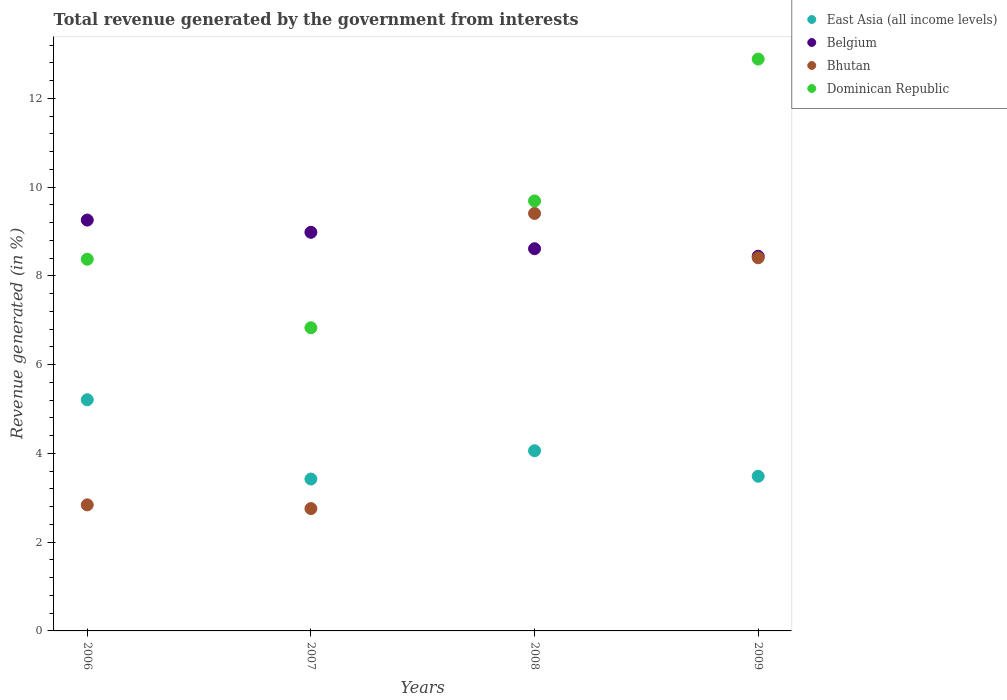How many different coloured dotlines are there?
Your response must be concise. 4. Is the number of dotlines equal to the number of legend labels?
Keep it short and to the point. Yes. What is the total revenue generated in Bhutan in 2006?
Provide a short and direct response. 2.84. Across all years, what is the maximum total revenue generated in Dominican Republic?
Ensure brevity in your answer.  12.88. Across all years, what is the minimum total revenue generated in Belgium?
Ensure brevity in your answer.  8.44. What is the total total revenue generated in Bhutan in the graph?
Provide a short and direct response. 23.41. What is the difference between the total revenue generated in Belgium in 2008 and that in 2009?
Keep it short and to the point. 0.17. What is the difference between the total revenue generated in Bhutan in 2006 and the total revenue generated in Dominican Republic in 2007?
Provide a succinct answer. -3.99. What is the average total revenue generated in Bhutan per year?
Ensure brevity in your answer.  5.85. In the year 2008, what is the difference between the total revenue generated in East Asia (all income levels) and total revenue generated in Belgium?
Your answer should be compact. -4.55. In how many years, is the total revenue generated in Bhutan greater than 4 %?
Your response must be concise. 2. What is the ratio of the total revenue generated in Belgium in 2006 to that in 2008?
Your response must be concise. 1.07. Is the difference between the total revenue generated in East Asia (all income levels) in 2006 and 2009 greater than the difference between the total revenue generated in Belgium in 2006 and 2009?
Your response must be concise. Yes. What is the difference between the highest and the second highest total revenue generated in Belgium?
Your response must be concise. 0.28. What is the difference between the highest and the lowest total revenue generated in Dominican Republic?
Give a very brief answer. 6.05. Is the sum of the total revenue generated in Bhutan in 2007 and 2009 greater than the maximum total revenue generated in Belgium across all years?
Make the answer very short. Yes. Is it the case that in every year, the sum of the total revenue generated in Bhutan and total revenue generated in Dominican Republic  is greater than the sum of total revenue generated in Belgium and total revenue generated in East Asia (all income levels)?
Your answer should be very brief. No. Is it the case that in every year, the sum of the total revenue generated in Belgium and total revenue generated in East Asia (all income levels)  is greater than the total revenue generated in Bhutan?
Give a very brief answer. Yes. Does the total revenue generated in Bhutan monotonically increase over the years?
Your answer should be compact. No. Is the total revenue generated in Belgium strictly greater than the total revenue generated in Bhutan over the years?
Keep it short and to the point. No. How many dotlines are there?
Give a very brief answer. 4. What is the difference between two consecutive major ticks on the Y-axis?
Offer a terse response. 2. Are the values on the major ticks of Y-axis written in scientific E-notation?
Provide a short and direct response. No. Does the graph contain any zero values?
Ensure brevity in your answer.  No. How are the legend labels stacked?
Offer a very short reply. Vertical. What is the title of the graph?
Make the answer very short. Total revenue generated by the government from interests. What is the label or title of the X-axis?
Ensure brevity in your answer.  Years. What is the label or title of the Y-axis?
Your answer should be very brief. Revenue generated (in %). What is the Revenue generated (in %) of East Asia (all income levels) in 2006?
Your answer should be very brief. 5.21. What is the Revenue generated (in %) in Belgium in 2006?
Your answer should be very brief. 9.26. What is the Revenue generated (in %) of Bhutan in 2006?
Offer a terse response. 2.84. What is the Revenue generated (in %) in Dominican Republic in 2006?
Keep it short and to the point. 8.37. What is the Revenue generated (in %) in East Asia (all income levels) in 2007?
Your answer should be very brief. 3.42. What is the Revenue generated (in %) of Belgium in 2007?
Provide a short and direct response. 8.98. What is the Revenue generated (in %) of Bhutan in 2007?
Provide a succinct answer. 2.76. What is the Revenue generated (in %) of Dominican Republic in 2007?
Your answer should be compact. 6.83. What is the Revenue generated (in %) of East Asia (all income levels) in 2008?
Offer a terse response. 4.06. What is the Revenue generated (in %) in Belgium in 2008?
Make the answer very short. 8.61. What is the Revenue generated (in %) of Bhutan in 2008?
Keep it short and to the point. 9.41. What is the Revenue generated (in %) of Dominican Republic in 2008?
Keep it short and to the point. 9.69. What is the Revenue generated (in %) in East Asia (all income levels) in 2009?
Your answer should be very brief. 3.48. What is the Revenue generated (in %) of Belgium in 2009?
Your answer should be very brief. 8.44. What is the Revenue generated (in %) of Bhutan in 2009?
Offer a very short reply. 8.41. What is the Revenue generated (in %) in Dominican Republic in 2009?
Offer a terse response. 12.88. Across all years, what is the maximum Revenue generated (in %) of East Asia (all income levels)?
Your response must be concise. 5.21. Across all years, what is the maximum Revenue generated (in %) in Belgium?
Provide a succinct answer. 9.26. Across all years, what is the maximum Revenue generated (in %) of Bhutan?
Offer a very short reply. 9.41. Across all years, what is the maximum Revenue generated (in %) in Dominican Republic?
Your answer should be very brief. 12.88. Across all years, what is the minimum Revenue generated (in %) of East Asia (all income levels)?
Offer a terse response. 3.42. Across all years, what is the minimum Revenue generated (in %) in Belgium?
Your answer should be very brief. 8.44. Across all years, what is the minimum Revenue generated (in %) in Bhutan?
Give a very brief answer. 2.76. Across all years, what is the minimum Revenue generated (in %) of Dominican Republic?
Offer a very short reply. 6.83. What is the total Revenue generated (in %) in East Asia (all income levels) in the graph?
Your answer should be very brief. 16.18. What is the total Revenue generated (in %) in Belgium in the graph?
Offer a very short reply. 35.29. What is the total Revenue generated (in %) in Bhutan in the graph?
Your answer should be very brief. 23.41. What is the total Revenue generated (in %) in Dominican Republic in the graph?
Offer a terse response. 37.78. What is the difference between the Revenue generated (in %) of East Asia (all income levels) in 2006 and that in 2007?
Your response must be concise. 1.79. What is the difference between the Revenue generated (in %) of Belgium in 2006 and that in 2007?
Offer a terse response. 0.28. What is the difference between the Revenue generated (in %) of Bhutan in 2006 and that in 2007?
Your response must be concise. 0.08. What is the difference between the Revenue generated (in %) of Dominican Republic in 2006 and that in 2007?
Provide a succinct answer. 1.54. What is the difference between the Revenue generated (in %) in East Asia (all income levels) in 2006 and that in 2008?
Your answer should be compact. 1.15. What is the difference between the Revenue generated (in %) of Belgium in 2006 and that in 2008?
Ensure brevity in your answer.  0.65. What is the difference between the Revenue generated (in %) of Bhutan in 2006 and that in 2008?
Your answer should be compact. -6.57. What is the difference between the Revenue generated (in %) of Dominican Republic in 2006 and that in 2008?
Make the answer very short. -1.31. What is the difference between the Revenue generated (in %) of East Asia (all income levels) in 2006 and that in 2009?
Your answer should be compact. 1.72. What is the difference between the Revenue generated (in %) of Belgium in 2006 and that in 2009?
Your answer should be compact. 0.82. What is the difference between the Revenue generated (in %) in Bhutan in 2006 and that in 2009?
Your answer should be very brief. -5.57. What is the difference between the Revenue generated (in %) in Dominican Republic in 2006 and that in 2009?
Provide a succinct answer. -4.51. What is the difference between the Revenue generated (in %) of East Asia (all income levels) in 2007 and that in 2008?
Provide a short and direct response. -0.64. What is the difference between the Revenue generated (in %) of Belgium in 2007 and that in 2008?
Give a very brief answer. 0.37. What is the difference between the Revenue generated (in %) in Bhutan in 2007 and that in 2008?
Keep it short and to the point. -6.65. What is the difference between the Revenue generated (in %) in Dominican Republic in 2007 and that in 2008?
Provide a succinct answer. -2.86. What is the difference between the Revenue generated (in %) of East Asia (all income levels) in 2007 and that in 2009?
Your answer should be very brief. -0.06. What is the difference between the Revenue generated (in %) in Belgium in 2007 and that in 2009?
Ensure brevity in your answer.  0.54. What is the difference between the Revenue generated (in %) of Bhutan in 2007 and that in 2009?
Provide a succinct answer. -5.65. What is the difference between the Revenue generated (in %) of Dominican Republic in 2007 and that in 2009?
Ensure brevity in your answer.  -6.05. What is the difference between the Revenue generated (in %) of East Asia (all income levels) in 2008 and that in 2009?
Your response must be concise. 0.57. What is the difference between the Revenue generated (in %) of Belgium in 2008 and that in 2009?
Make the answer very short. 0.17. What is the difference between the Revenue generated (in %) in Dominican Republic in 2008 and that in 2009?
Offer a very short reply. -3.2. What is the difference between the Revenue generated (in %) in East Asia (all income levels) in 2006 and the Revenue generated (in %) in Belgium in 2007?
Provide a succinct answer. -3.77. What is the difference between the Revenue generated (in %) of East Asia (all income levels) in 2006 and the Revenue generated (in %) of Bhutan in 2007?
Provide a short and direct response. 2.45. What is the difference between the Revenue generated (in %) in East Asia (all income levels) in 2006 and the Revenue generated (in %) in Dominican Republic in 2007?
Your answer should be very brief. -1.62. What is the difference between the Revenue generated (in %) in Belgium in 2006 and the Revenue generated (in %) in Bhutan in 2007?
Keep it short and to the point. 6.5. What is the difference between the Revenue generated (in %) in Belgium in 2006 and the Revenue generated (in %) in Dominican Republic in 2007?
Your response must be concise. 2.43. What is the difference between the Revenue generated (in %) of Bhutan in 2006 and the Revenue generated (in %) of Dominican Republic in 2007?
Keep it short and to the point. -3.99. What is the difference between the Revenue generated (in %) of East Asia (all income levels) in 2006 and the Revenue generated (in %) of Belgium in 2008?
Offer a very short reply. -3.4. What is the difference between the Revenue generated (in %) in East Asia (all income levels) in 2006 and the Revenue generated (in %) in Bhutan in 2008?
Your answer should be very brief. -4.2. What is the difference between the Revenue generated (in %) in East Asia (all income levels) in 2006 and the Revenue generated (in %) in Dominican Republic in 2008?
Provide a short and direct response. -4.48. What is the difference between the Revenue generated (in %) of Belgium in 2006 and the Revenue generated (in %) of Bhutan in 2008?
Provide a succinct answer. -0.15. What is the difference between the Revenue generated (in %) in Belgium in 2006 and the Revenue generated (in %) in Dominican Republic in 2008?
Your response must be concise. -0.43. What is the difference between the Revenue generated (in %) in Bhutan in 2006 and the Revenue generated (in %) in Dominican Republic in 2008?
Keep it short and to the point. -6.85. What is the difference between the Revenue generated (in %) of East Asia (all income levels) in 2006 and the Revenue generated (in %) of Belgium in 2009?
Offer a terse response. -3.23. What is the difference between the Revenue generated (in %) in East Asia (all income levels) in 2006 and the Revenue generated (in %) in Bhutan in 2009?
Your answer should be compact. -3.2. What is the difference between the Revenue generated (in %) in East Asia (all income levels) in 2006 and the Revenue generated (in %) in Dominican Republic in 2009?
Your response must be concise. -7.68. What is the difference between the Revenue generated (in %) of Belgium in 2006 and the Revenue generated (in %) of Bhutan in 2009?
Provide a short and direct response. 0.85. What is the difference between the Revenue generated (in %) in Belgium in 2006 and the Revenue generated (in %) in Dominican Republic in 2009?
Offer a terse response. -3.63. What is the difference between the Revenue generated (in %) of Bhutan in 2006 and the Revenue generated (in %) of Dominican Republic in 2009?
Your answer should be very brief. -10.04. What is the difference between the Revenue generated (in %) in East Asia (all income levels) in 2007 and the Revenue generated (in %) in Belgium in 2008?
Your response must be concise. -5.19. What is the difference between the Revenue generated (in %) of East Asia (all income levels) in 2007 and the Revenue generated (in %) of Bhutan in 2008?
Provide a short and direct response. -5.98. What is the difference between the Revenue generated (in %) of East Asia (all income levels) in 2007 and the Revenue generated (in %) of Dominican Republic in 2008?
Ensure brevity in your answer.  -6.27. What is the difference between the Revenue generated (in %) of Belgium in 2007 and the Revenue generated (in %) of Bhutan in 2008?
Make the answer very short. -0.42. What is the difference between the Revenue generated (in %) in Belgium in 2007 and the Revenue generated (in %) in Dominican Republic in 2008?
Your response must be concise. -0.71. What is the difference between the Revenue generated (in %) of Bhutan in 2007 and the Revenue generated (in %) of Dominican Republic in 2008?
Offer a very short reply. -6.93. What is the difference between the Revenue generated (in %) in East Asia (all income levels) in 2007 and the Revenue generated (in %) in Belgium in 2009?
Offer a terse response. -5.02. What is the difference between the Revenue generated (in %) of East Asia (all income levels) in 2007 and the Revenue generated (in %) of Bhutan in 2009?
Offer a very short reply. -4.98. What is the difference between the Revenue generated (in %) of East Asia (all income levels) in 2007 and the Revenue generated (in %) of Dominican Republic in 2009?
Offer a terse response. -9.46. What is the difference between the Revenue generated (in %) of Belgium in 2007 and the Revenue generated (in %) of Bhutan in 2009?
Your response must be concise. 0.57. What is the difference between the Revenue generated (in %) in Belgium in 2007 and the Revenue generated (in %) in Dominican Republic in 2009?
Your answer should be compact. -3.9. What is the difference between the Revenue generated (in %) in Bhutan in 2007 and the Revenue generated (in %) in Dominican Republic in 2009?
Make the answer very short. -10.13. What is the difference between the Revenue generated (in %) in East Asia (all income levels) in 2008 and the Revenue generated (in %) in Belgium in 2009?
Provide a short and direct response. -4.38. What is the difference between the Revenue generated (in %) of East Asia (all income levels) in 2008 and the Revenue generated (in %) of Bhutan in 2009?
Provide a short and direct response. -4.35. What is the difference between the Revenue generated (in %) in East Asia (all income levels) in 2008 and the Revenue generated (in %) in Dominican Republic in 2009?
Give a very brief answer. -8.82. What is the difference between the Revenue generated (in %) of Belgium in 2008 and the Revenue generated (in %) of Bhutan in 2009?
Give a very brief answer. 0.2. What is the difference between the Revenue generated (in %) in Belgium in 2008 and the Revenue generated (in %) in Dominican Republic in 2009?
Give a very brief answer. -4.27. What is the difference between the Revenue generated (in %) of Bhutan in 2008 and the Revenue generated (in %) of Dominican Republic in 2009?
Provide a short and direct response. -3.48. What is the average Revenue generated (in %) in East Asia (all income levels) per year?
Make the answer very short. 4.04. What is the average Revenue generated (in %) of Belgium per year?
Provide a short and direct response. 8.82. What is the average Revenue generated (in %) in Bhutan per year?
Ensure brevity in your answer.  5.85. What is the average Revenue generated (in %) of Dominican Republic per year?
Keep it short and to the point. 9.44. In the year 2006, what is the difference between the Revenue generated (in %) of East Asia (all income levels) and Revenue generated (in %) of Belgium?
Give a very brief answer. -4.05. In the year 2006, what is the difference between the Revenue generated (in %) of East Asia (all income levels) and Revenue generated (in %) of Bhutan?
Your answer should be very brief. 2.37. In the year 2006, what is the difference between the Revenue generated (in %) in East Asia (all income levels) and Revenue generated (in %) in Dominican Republic?
Your answer should be very brief. -3.17. In the year 2006, what is the difference between the Revenue generated (in %) of Belgium and Revenue generated (in %) of Bhutan?
Offer a terse response. 6.42. In the year 2006, what is the difference between the Revenue generated (in %) of Belgium and Revenue generated (in %) of Dominican Republic?
Provide a succinct answer. 0.88. In the year 2006, what is the difference between the Revenue generated (in %) of Bhutan and Revenue generated (in %) of Dominican Republic?
Offer a terse response. -5.53. In the year 2007, what is the difference between the Revenue generated (in %) in East Asia (all income levels) and Revenue generated (in %) in Belgium?
Your response must be concise. -5.56. In the year 2007, what is the difference between the Revenue generated (in %) of East Asia (all income levels) and Revenue generated (in %) of Bhutan?
Ensure brevity in your answer.  0.67. In the year 2007, what is the difference between the Revenue generated (in %) of East Asia (all income levels) and Revenue generated (in %) of Dominican Republic?
Give a very brief answer. -3.41. In the year 2007, what is the difference between the Revenue generated (in %) of Belgium and Revenue generated (in %) of Bhutan?
Ensure brevity in your answer.  6.22. In the year 2007, what is the difference between the Revenue generated (in %) in Belgium and Revenue generated (in %) in Dominican Republic?
Offer a very short reply. 2.15. In the year 2007, what is the difference between the Revenue generated (in %) of Bhutan and Revenue generated (in %) of Dominican Republic?
Keep it short and to the point. -4.07. In the year 2008, what is the difference between the Revenue generated (in %) in East Asia (all income levels) and Revenue generated (in %) in Belgium?
Your answer should be very brief. -4.55. In the year 2008, what is the difference between the Revenue generated (in %) in East Asia (all income levels) and Revenue generated (in %) in Bhutan?
Your response must be concise. -5.35. In the year 2008, what is the difference between the Revenue generated (in %) in East Asia (all income levels) and Revenue generated (in %) in Dominican Republic?
Keep it short and to the point. -5.63. In the year 2008, what is the difference between the Revenue generated (in %) in Belgium and Revenue generated (in %) in Bhutan?
Your answer should be very brief. -0.79. In the year 2008, what is the difference between the Revenue generated (in %) in Belgium and Revenue generated (in %) in Dominican Republic?
Your answer should be very brief. -1.08. In the year 2008, what is the difference between the Revenue generated (in %) of Bhutan and Revenue generated (in %) of Dominican Republic?
Your answer should be compact. -0.28. In the year 2009, what is the difference between the Revenue generated (in %) of East Asia (all income levels) and Revenue generated (in %) of Belgium?
Your response must be concise. -4.96. In the year 2009, what is the difference between the Revenue generated (in %) in East Asia (all income levels) and Revenue generated (in %) in Bhutan?
Give a very brief answer. -4.92. In the year 2009, what is the difference between the Revenue generated (in %) of East Asia (all income levels) and Revenue generated (in %) of Dominican Republic?
Your response must be concise. -9.4. In the year 2009, what is the difference between the Revenue generated (in %) in Belgium and Revenue generated (in %) in Bhutan?
Offer a terse response. 0.03. In the year 2009, what is the difference between the Revenue generated (in %) of Belgium and Revenue generated (in %) of Dominican Republic?
Keep it short and to the point. -4.44. In the year 2009, what is the difference between the Revenue generated (in %) in Bhutan and Revenue generated (in %) in Dominican Republic?
Make the answer very short. -4.48. What is the ratio of the Revenue generated (in %) of East Asia (all income levels) in 2006 to that in 2007?
Your answer should be compact. 1.52. What is the ratio of the Revenue generated (in %) of Belgium in 2006 to that in 2007?
Your answer should be compact. 1.03. What is the ratio of the Revenue generated (in %) in Bhutan in 2006 to that in 2007?
Give a very brief answer. 1.03. What is the ratio of the Revenue generated (in %) of Dominican Republic in 2006 to that in 2007?
Keep it short and to the point. 1.23. What is the ratio of the Revenue generated (in %) of East Asia (all income levels) in 2006 to that in 2008?
Ensure brevity in your answer.  1.28. What is the ratio of the Revenue generated (in %) of Belgium in 2006 to that in 2008?
Your answer should be compact. 1.07. What is the ratio of the Revenue generated (in %) of Bhutan in 2006 to that in 2008?
Keep it short and to the point. 0.3. What is the ratio of the Revenue generated (in %) in Dominican Republic in 2006 to that in 2008?
Your answer should be very brief. 0.86. What is the ratio of the Revenue generated (in %) of East Asia (all income levels) in 2006 to that in 2009?
Your answer should be compact. 1.49. What is the ratio of the Revenue generated (in %) of Belgium in 2006 to that in 2009?
Make the answer very short. 1.1. What is the ratio of the Revenue generated (in %) of Bhutan in 2006 to that in 2009?
Ensure brevity in your answer.  0.34. What is the ratio of the Revenue generated (in %) of Dominican Republic in 2006 to that in 2009?
Provide a succinct answer. 0.65. What is the ratio of the Revenue generated (in %) of East Asia (all income levels) in 2007 to that in 2008?
Keep it short and to the point. 0.84. What is the ratio of the Revenue generated (in %) of Belgium in 2007 to that in 2008?
Keep it short and to the point. 1.04. What is the ratio of the Revenue generated (in %) in Bhutan in 2007 to that in 2008?
Keep it short and to the point. 0.29. What is the ratio of the Revenue generated (in %) in Dominican Republic in 2007 to that in 2008?
Give a very brief answer. 0.7. What is the ratio of the Revenue generated (in %) in East Asia (all income levels) in 2007 to that in 2009?
Offer a very short reply. 0.98. What is the ratio of the Revenue generated (in %) in Belgium in 2007 to that in 2009?
Offer a very short reply. 1.06. What is the ratio of the Revenue generated (in %) of Bhutan in 2007 to that in 2009?
Provide a succinct answer. 0.33. What is the ratio of the Revenue generated (in %) in Dominican Republic in 2007 to that in 2009?
Offer a terse response. 0.53. What is the ratio of the Revenue generated (in %) in East Asia (all income levels) in 2008 to that in 2009?
Your answer should be compact. 1.16. What is the ratio of the Revenue generated (in %) in Belgium in 2008 to that in 2009?
Your answer should be compact. 1.02. What is the ratio of the Revenue generated (in %) of Bhutan in 2008 to that in 2009?
Provide a short and direct response. 1.12. What is the ratio of the Revenue generated (in %) of Dominican Republic in 2008 to that in 2009?
Give a very brief answer. 0.75. What is the difference between the highest and the second highest Revenue generated (in %) of East Asia (all income levels)?
Keep it short and to the point. 1.15. What is the difference between the highest and the second highest Revenue generated (in %) in Belgium?
Give a very brief answer. 0.28. What is the difference between the highest and the second highest Revenue generated (in %) in Dominican Republic?
Offer a terse response. 3.2. What is the difference between the highest and the lowest Revenue generated (in %) in East Asia (all income levels)?
Your response must be concise. 1.79. What is the difference between the highest and the lowest Revenue generated (in %) in Belgium?
Keep it short and to the point. 0.82. What is the difference between the highest and the lowest Revenue generated (in %) in Bhutan?
Make the answer very short. 6.65. What is the difference between the highest and the lowest Revenue generated (in %) in Dominican Republic?
Keep it short and to the point. 6.05. 